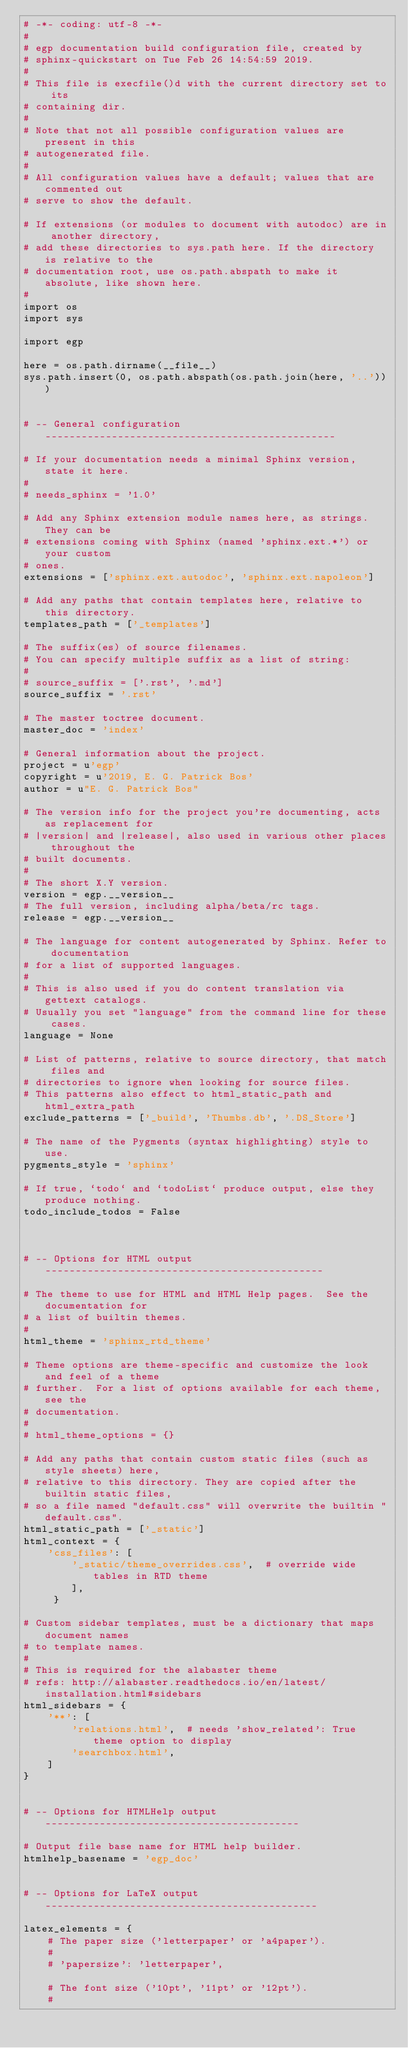Convert code to text. <code><loc_0><loc_0><loc_500><loc_500><_Python_># -*- coding: utf-8 -*-
#
# egp documentation build configuration file, created by
# sphinx-quickstart on Tue Feb 26 14:54:59 2019.
#
# This file is execfile()d with the current directory set to its
# containing dir.
#
# Note that not all possible configuration values are present in this
# autogenerated file.
#
# All configuration values have a default; values that are commented out
# serve to show the default.

# If extensions (or modules to document with autodoc) are in another directory,
# add these directories to sys.path here. If the directory is relative to the
# documentation root, use os.path.abspath to make it absolute, like shown here.
#
import os
import sys

import egp

here = os.path.dirname(__file__)
sys.path.insert(0, os.path.abspath(os.path.join(here, '..')))


# -- General configuration ------------------------------------------------

# If your documentation needs a minimal Sphinx version, state it here.
#
# needs_sphinx = '1.0'

# Add any Sphinx extension module names here, as strings. They can be
# extensions coming with Sphinx (named 'sphinx.ext.*') or your custom
# ones.
extensions = ['sphinx.ext.autodoc', 'sphinx.ext.napoleon']

# Add any paths that contain templates here, relative to this directory.
templates_path = ['_templates']

# The suffix(es) of source filenames.
# You can specify multiple suffix as a list of string:
#
# source_suffix = ['.rst', '.md']
source_suffix = '.rst'

# The master toctree document.
master_doc = 'index'

# General information about the project.
project = u'egp'
copyright = u'2019, E. G. Patrick Bos'
author = u"E. G. Patrick Bos"

# The version info for the project you're documenting, acts as replacement for
# |version| and |release|, also used in various other places throughout the
# built documents.
#
# The short X.Y version.
version = egp.__version__
# The full version, including alpha/beta/rc tags.
release = egp.__version__

# The language for content autogenerated by Sphinx. Refer to documentation
# for a list of supported languages.
#
# This is also used if you do content translation via gettext catalogs.
# Usually you set "language" from the command line for these cases.
language = None

# List of patterns, relative to source directory, that match files and
# directories to ignore when looking for source files.
# This patterns also effect to html_static_path and html_extra_path
exclude_patterns = ['_build', 'Thumbs.db', '.DS_Store']

# The name of the Pygments (syntax highlighting) style to use.
pygments_style = 'sphinx'

# If true, `todo` and `todoList` produce output, else they produce nothing.
todo_include_todos = False



# -- Options for HTML output ----------------------------------------------

# The theme to use for HTML and HTML Help pages.  See the documentation for
# a list of builtin themes.
#
html_theme = 'sphinx_rtd_theme'

# Theme options are theme-specific and customize the look and feel of a theme
# further.  For a list of options available for each theme, see the
# documentation.
#
# html_theme_options = {}

# Add any paths that contain custom static files (such as style sheets) here,
# relative to this directory. They are copied after the builtin static files,
# so a file named "default.css" will overwrite the builtin "default.css".
html_static_path = ['_static']
html_context = {
    'css_files': [
        '_static/theme_overrides.css',  # override wide tables in RTD theme
        ],
     }

# Custom sidebar templates, must be a dictionary that maps document names
# to template names.
#
# This is required for the alabaster theme
# refs: http://alabaster.readthedocs.io/en/latest/installation.html#sidebars
html_sidebars = {
    '**': [
        'relations.html',  # needs 'show_related': True theme option to display
        'searchbox.html',
    ]
}


# -- Options for HTMLHelp output ------------------------------------------

# Output file base name for HTML help builder.
htmlhelp_basename = 'egp_doc'


# -- Options for LaTeX output ---------------------------------------------

latex_elements = {
    # The paper size ('letterpaper' or 'a4paper').
    #
    # 'papersize': 'letterpaper',

    # The font size ('10pt', '11pt' or '12pt').
    #</code> 